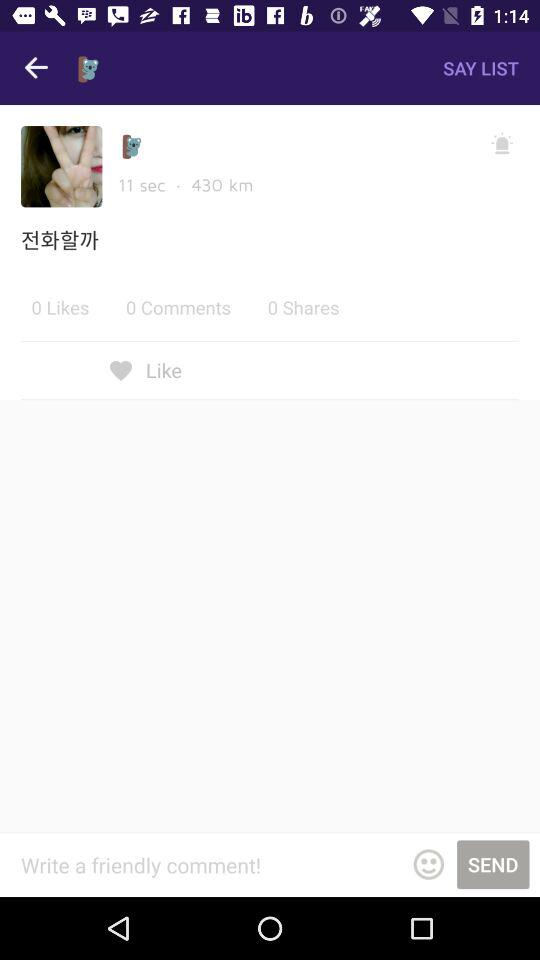How many comments are there? There are 0 comments. 